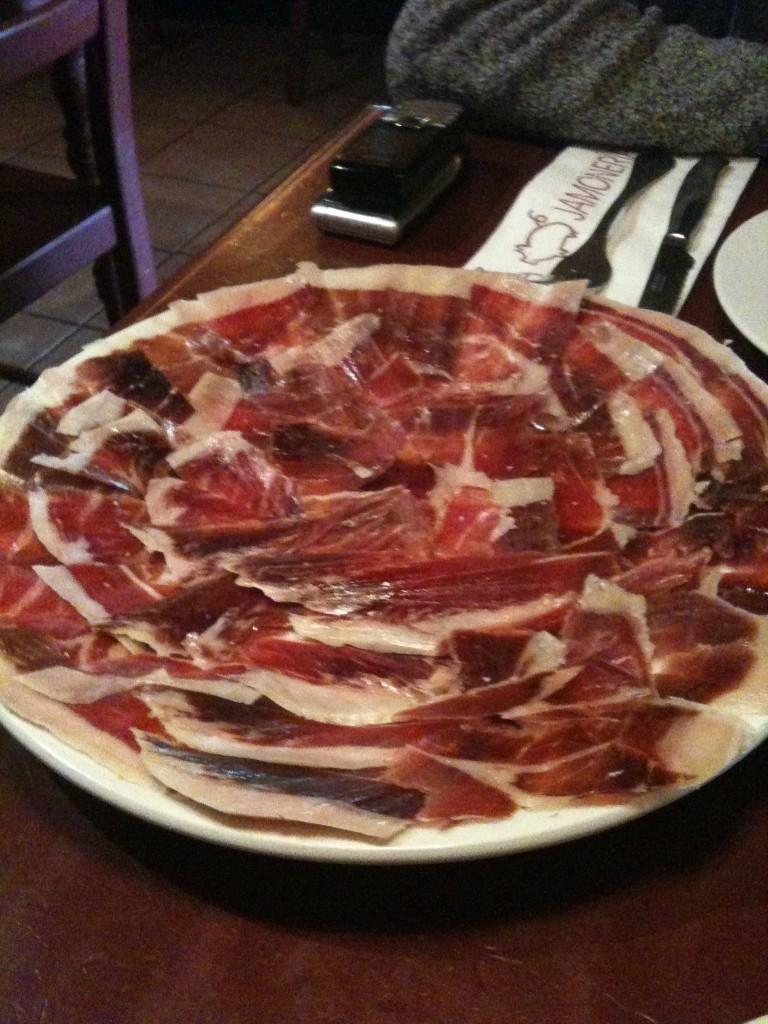What piece of furniture is present in the image? There is a table in the image. What is on the table? There is a plate with food on the table, as well as a knife and a fork. What electronic devices are on the table? There are cell phones on the table. Can you describe the seating arrangement in the image? There appears to be a chair in the image. Reasoning: Let'ing: Let's think step by step in order to produce the conversation. We start by identifying the main piece of furniture in the image, which is the table. Then, we describe the items that are on the table, including the plate with food, the knife, the fork, and the cell phones. Finally, we mention the seating arrangement by noting the presence of a chair in the image. Each question is designed to elicit a specific detail about the image that is known from the provided facts. Absurd Question/Answer: How many pigs are sitting on the table in the image? There are no pigs present in the image; the table has a plate with food, a knife, a fork, and cell phones. 